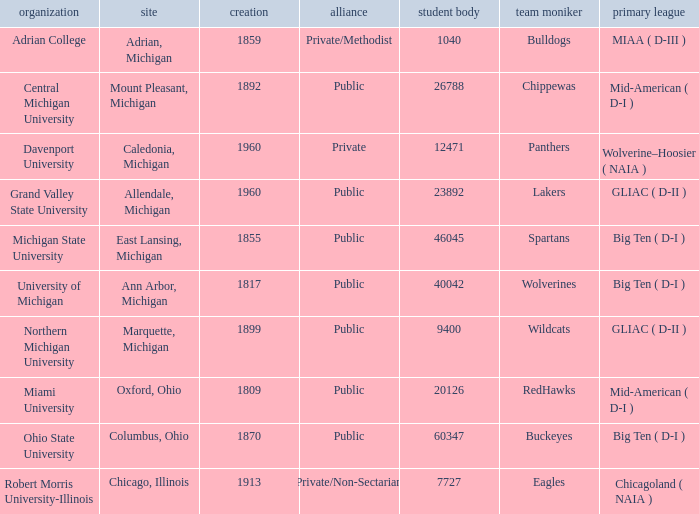What is the registration for the redhawks? 1.0. 